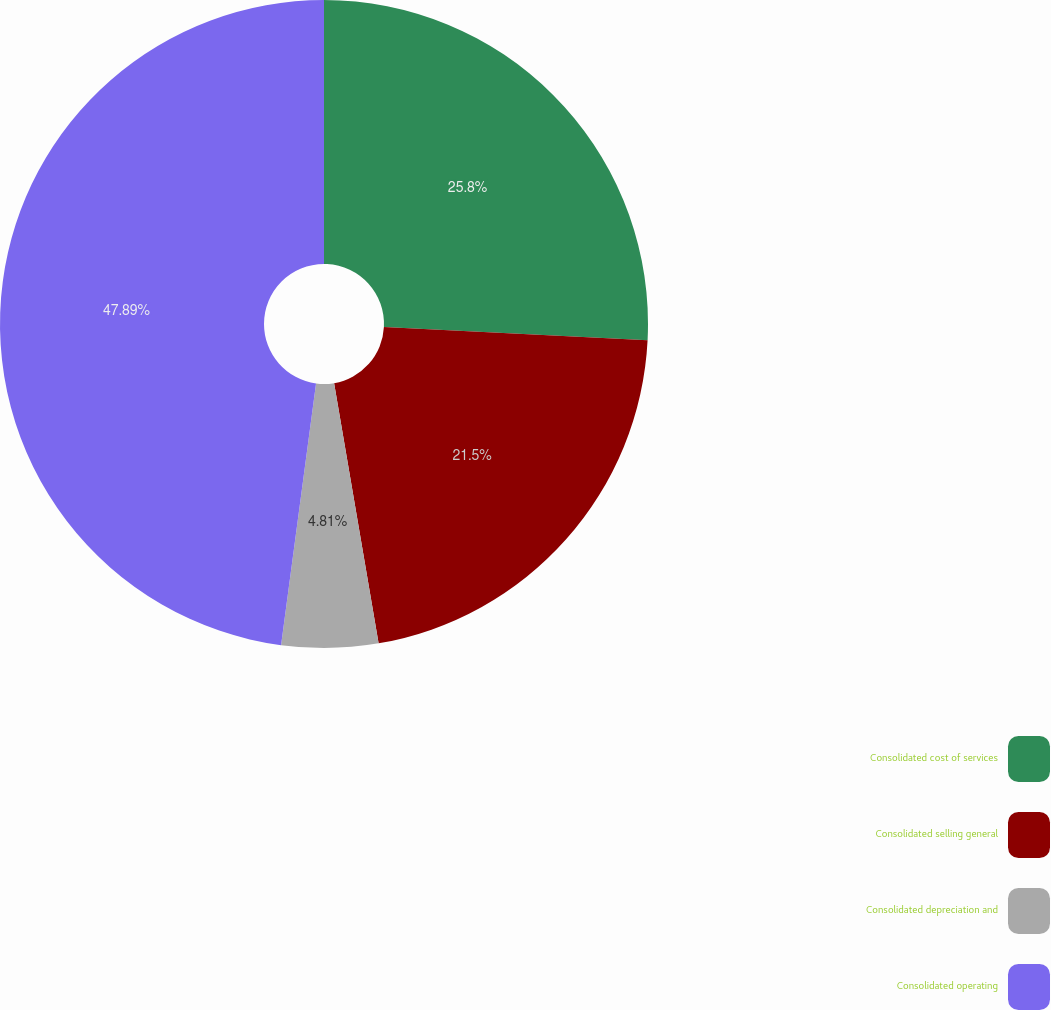Convert chart. <chart><loc_0><loc_0><loc_500><loc_500><pie_chart><fcel>Consolidated cost of services<fcel>Consolidated selling general<fcel>Consolidated depreciation and<fcel>Consolidated operating<nl><fcel>25.8%<fcel>21.5%<fcel>4.81%<fcel>47.88%<nl></chart> 